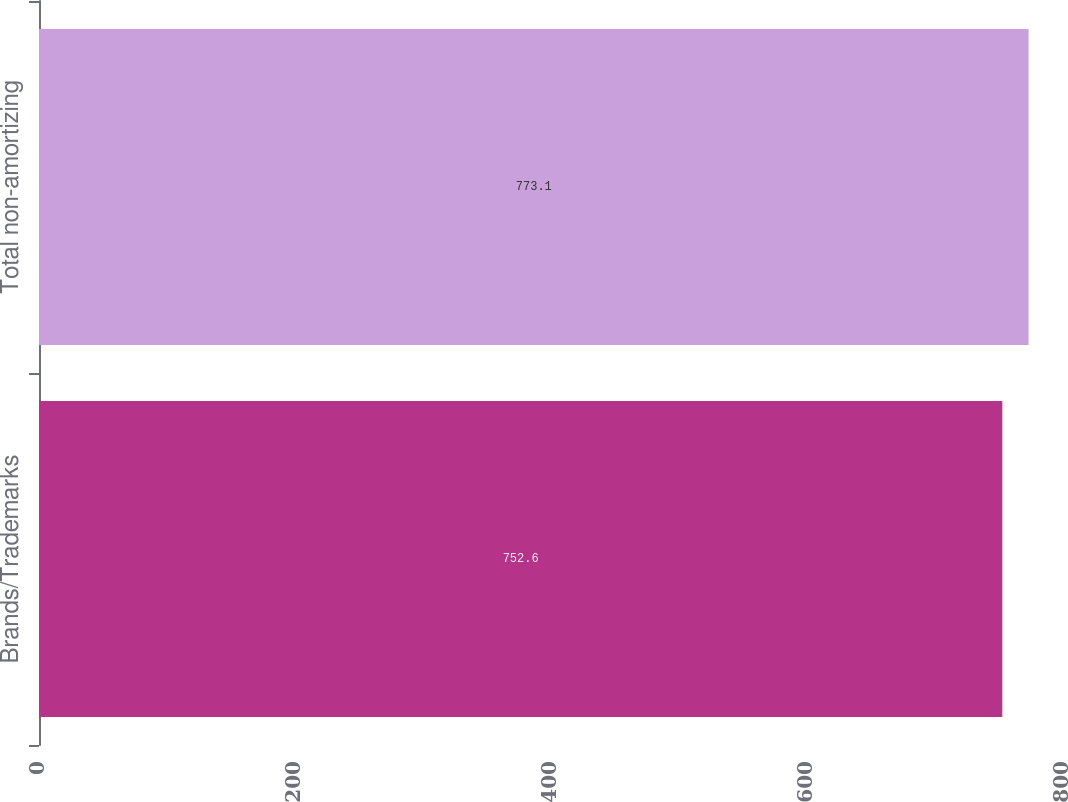<chart> <loc_0><loc_0><loc_500><loc_500><bar_chart><fcel>Brands/Trademarks<fcel>Total non-amortizing<nl><fcel>752.6<fcel>773.1<nl></chart> 